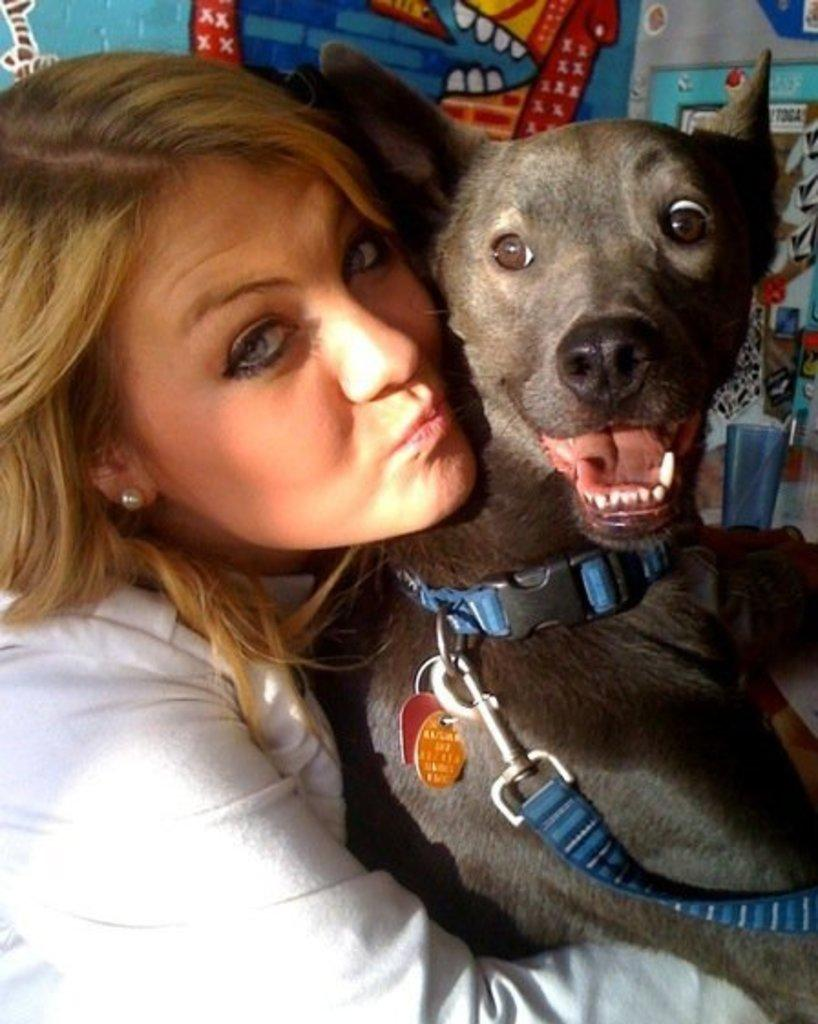Who is present in the image? There is a woman in the image. What is the woman holding? The woman is holding a dog. What can be seen in the background of the image? There is a glass and an object in the background of the image. What type of vegetable is the woman eating in the image? There is no vegetable present in the image, and the woman is not shown eating anything. 